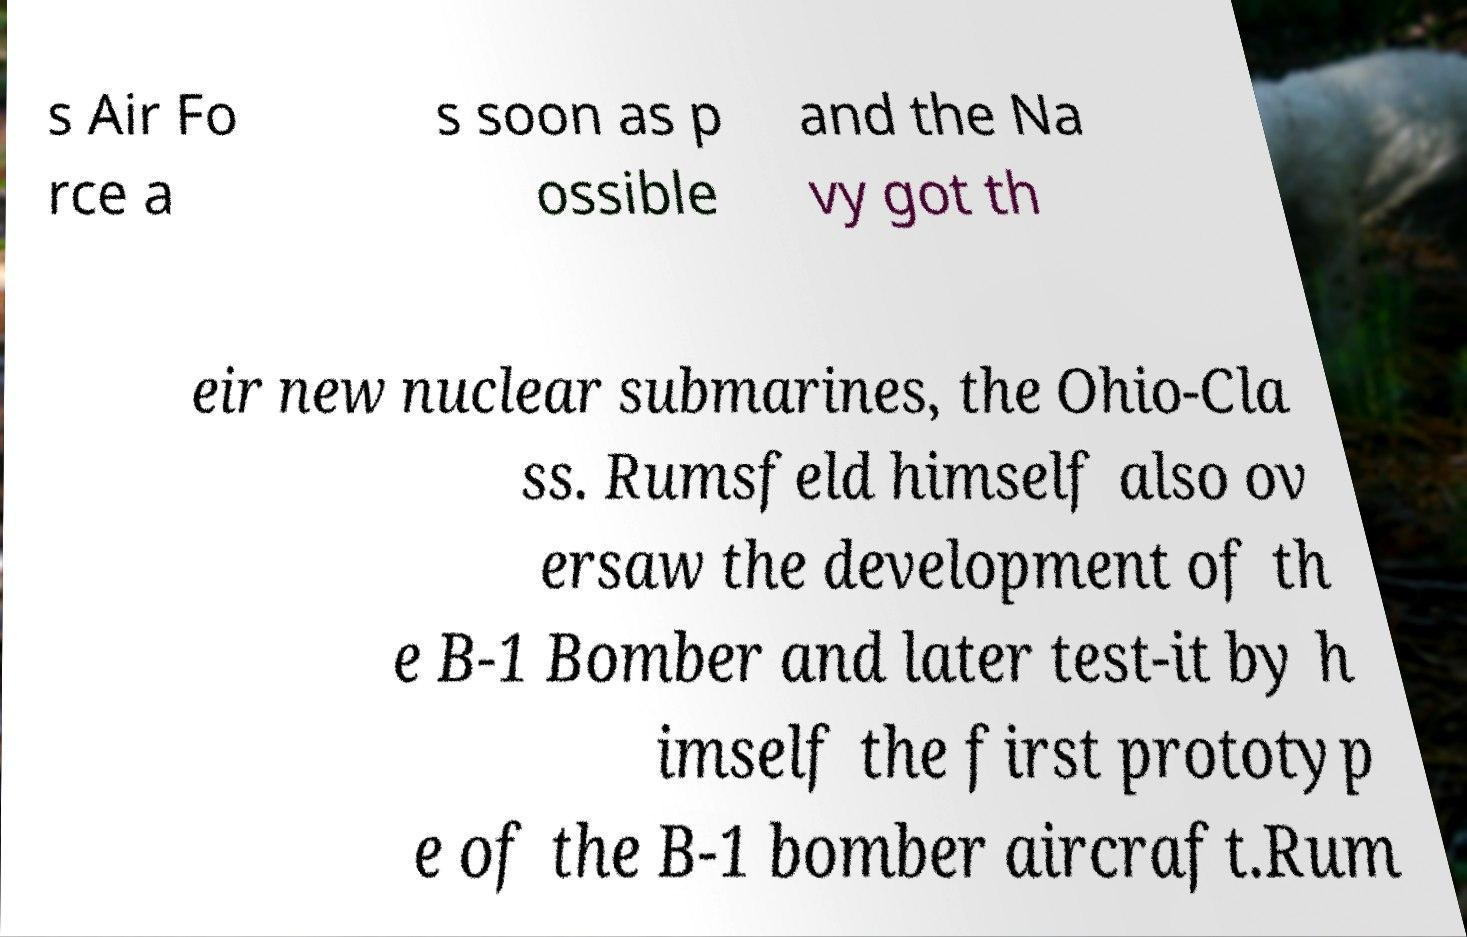There's text embedded in this image that I need extracted. Can you transcribe it verbatim? s Air Fo rce a s soon as p ossible and the Na vy got th eir new nuclear submarines, the Ohio-Cla ss. Rumsfeld himself also ov ersaw the development of th e B-1 Bomber and later test-it by h imself the first prototyp e of the B-1 bomber aircraft.Rum 